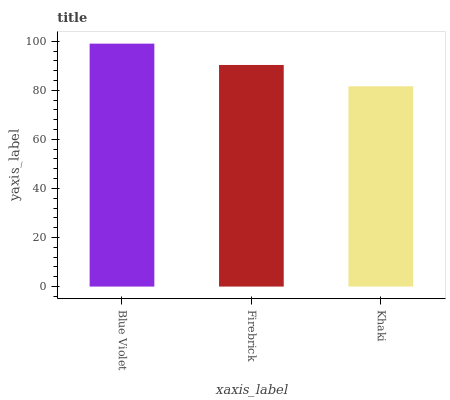Is Firebrick the minimum?
Answer yes or no. No. Is Firebrick the maximum?
Answer yes or no. No. Is Blue Violet greater than Firebrick?
Answer yes or no. Yes. Is Firebrick less than Blue Violet?
Answer yes or no. Yes. Is Firebrick greater than Blue Violet?
Answer yes or no. No. Is Blue Violet less than Firebrick?
Answer yes or no. No. Is Firebrick the high median?
Answer yes or no. Yes. Is Firebrick the low median?
Answer yes or no. Yes. Is Blue Violet the high median?
Answer yes or no. No. Is Khaki the low median?
Answer yes or no. No. 